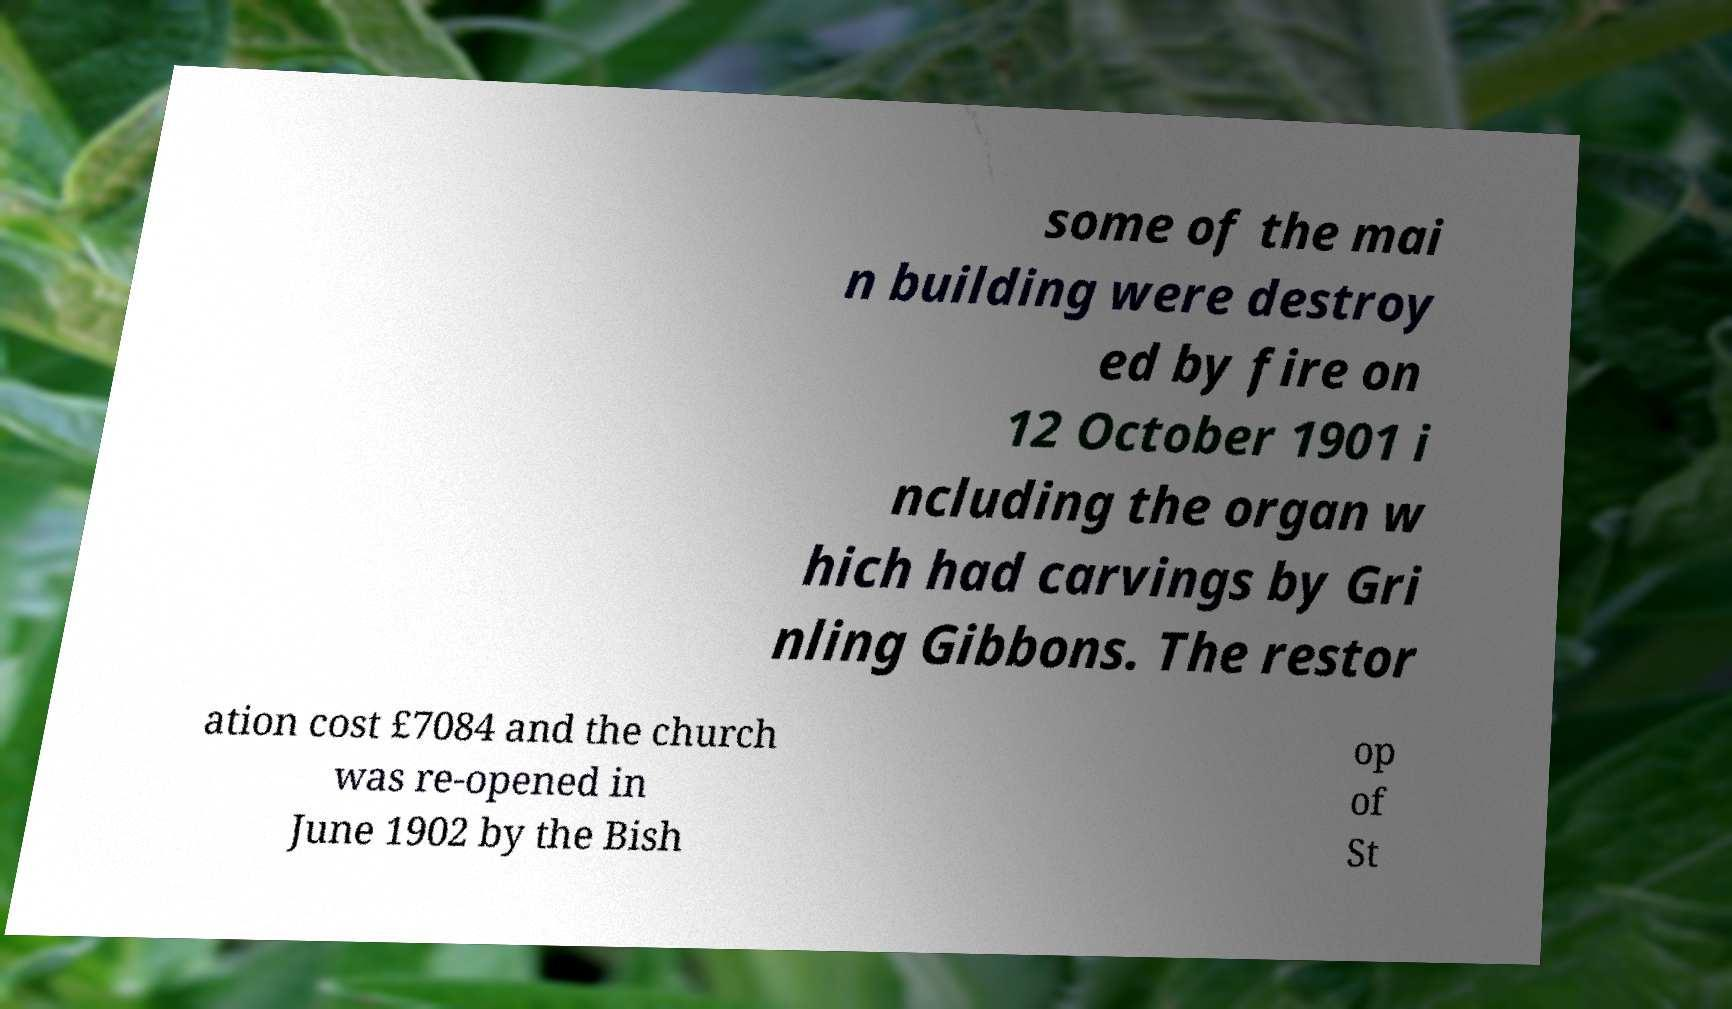Could you extract and type out the text from this image? some of the mai n building were destroy ed by fire on 12 October 1901 i ncluding the organ w hich had carvings by Gri nling Gibbons. The restor ation cost £7084 and the church was re-opened in June 1902 by the Bish op of St 